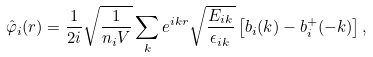<formula> <loc_0><loc_0><loc_500><loc_500>\hat { \varphi } _ { i } ( { r } ) = \frac { 1 } { 2 i } \sqrt { \frac { 1 } { n _ { i } V } } \sum _ { k } e ^ { i { k r } } \sqrt { \frac { E _ { i k } } { \epsilon _ { i k } } } \left [ b _ { i } ( { k } ) - b ^ { + } _ { i } ( - { k } ) \right ] ,</formula> 